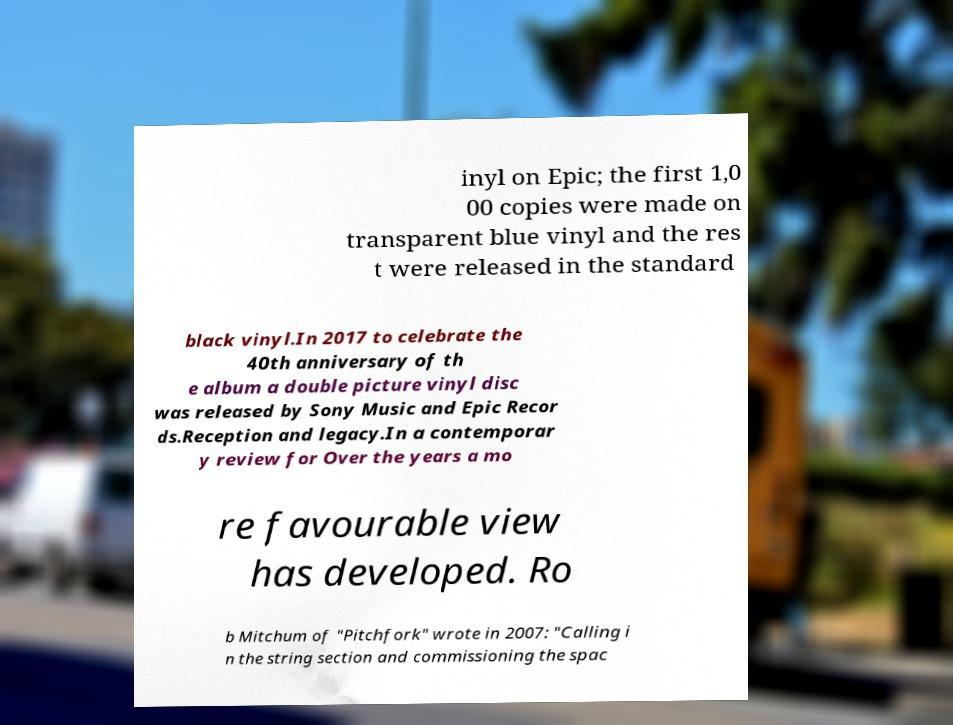Could you assist in decoding the text presented in this image and type it out clearly? inyl on Epic; the first 1,0 00 copies were made on transparent blue vinyl and the res t were released in the standard black vinyl.In 2017 to celebrate the 40th anniversary of th e album a double picture vinyl disc was released by Sony Music and Epic Recor ds.Reception and legacy.In a contemporar y review for Over the years a mo re favourable view has developed. Ro b Mitchum of "Pitchfork" wrote in 2007: "Calling i n the string section and commissioning the spac 